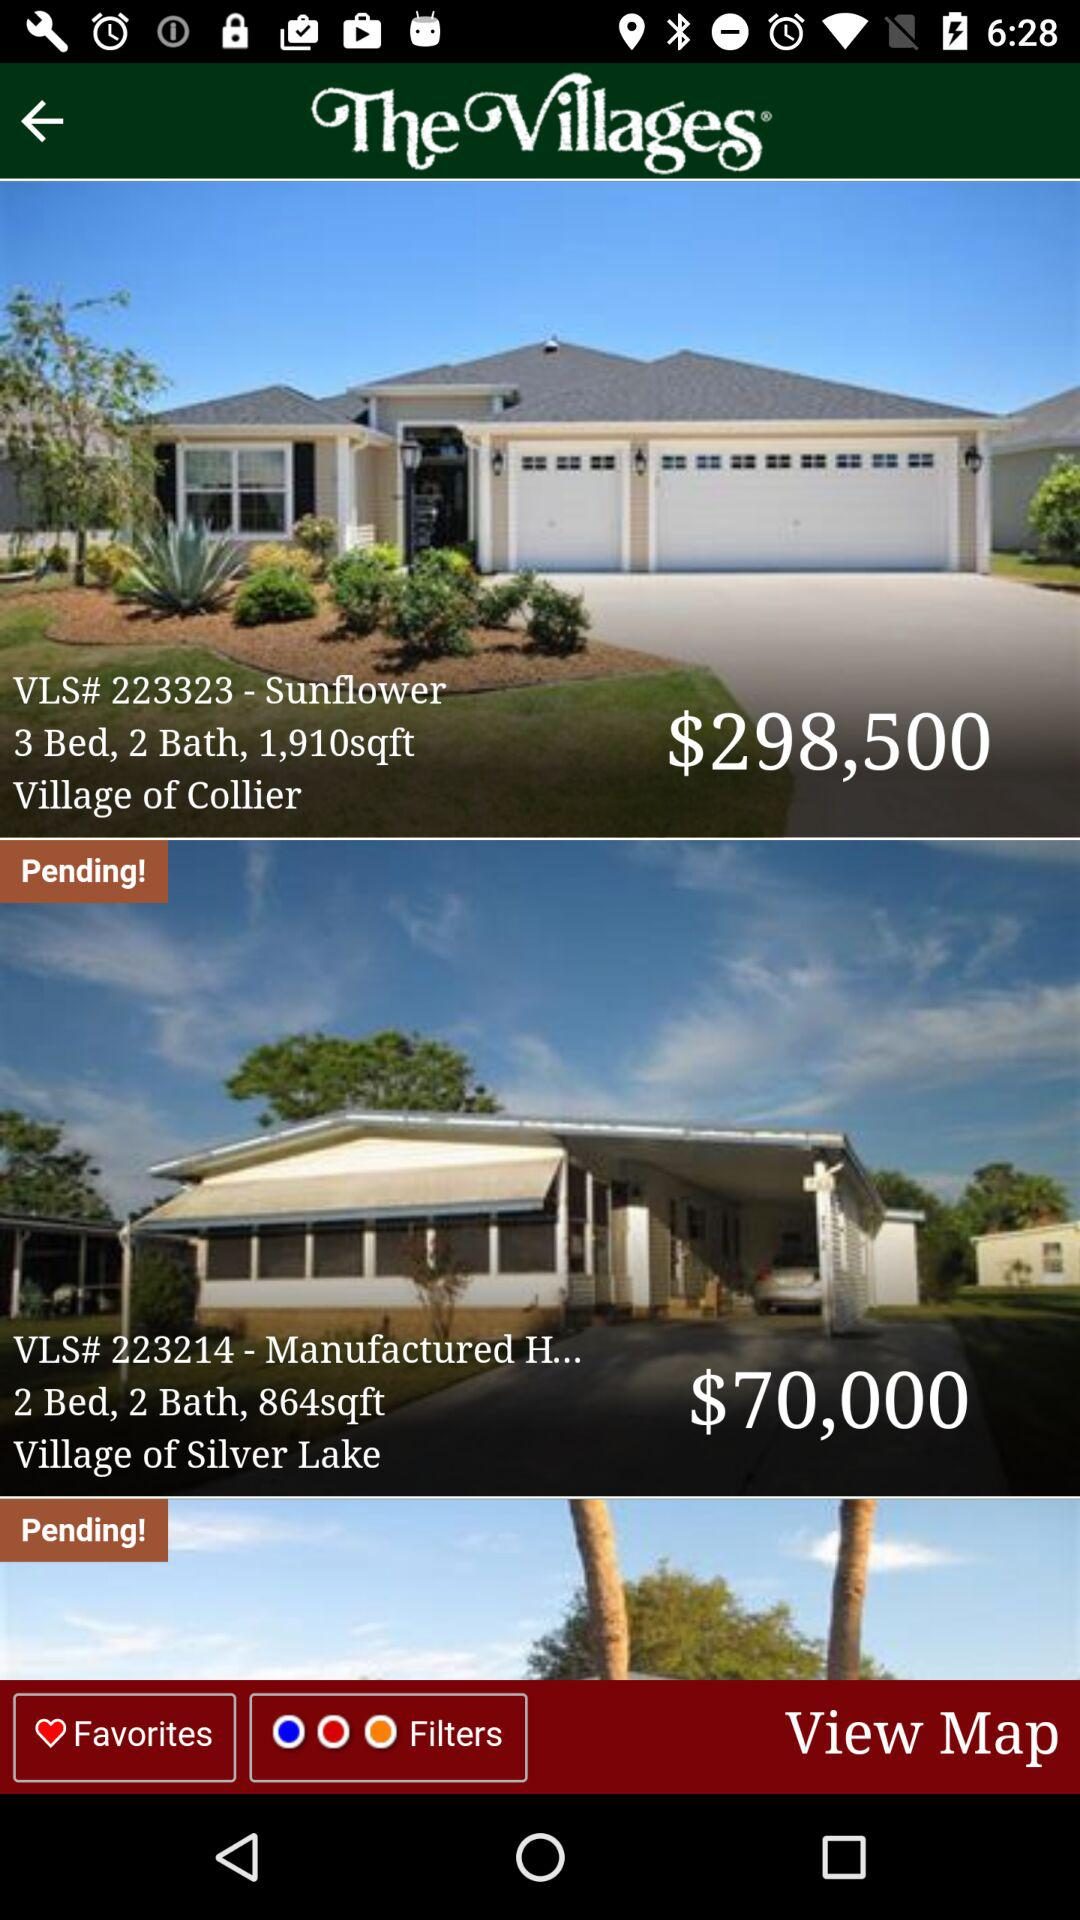What is the price of the "Village of Collier"? The price is $298,500. 